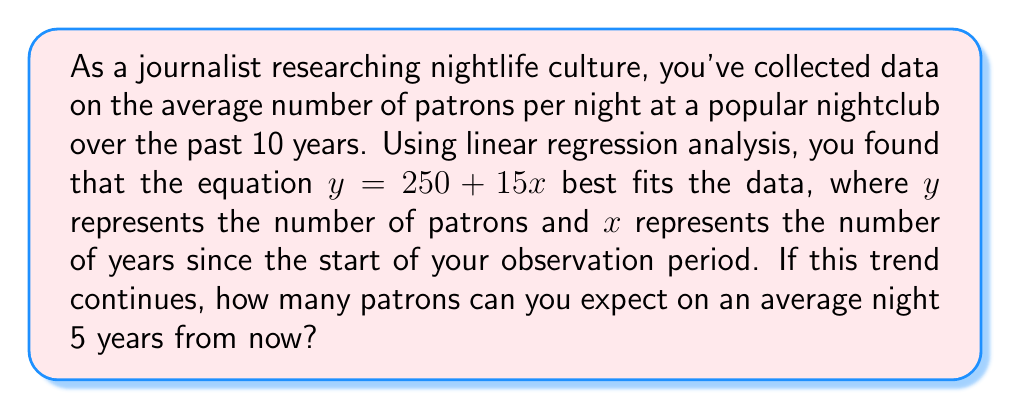Teach me how to tackle this problem. To solve this problem, we'll follow these steps:

1. Understand the given linear regression equation:
   $y = 250 + 15x$
   Where:
   - $y$ is the number of patrons
   - $x$ is the number of years since the start of the observation period
   - 250 is the y-intercept (initial number of patrons)
   - 15 is the slope (annual increase in patrons)

2. Determine the value of $x$ for 5 years from now:
   - The question asks about 5 years from now
   - Since we've already collected 10 years of data, 5 years from now would be year 15
   - Therefore, $x = 15$

3. Substitute $x = 15$ into the equation:
   $y = 250 + 15(15)$

4. Solve the equation:
   $y = 250 + 225$
   $y = 475$

Thus, based on the linear regression analysis, we can expect an average of 475 patrons per night 5 years from now if the trend continues.
Answer: 475 patrons 